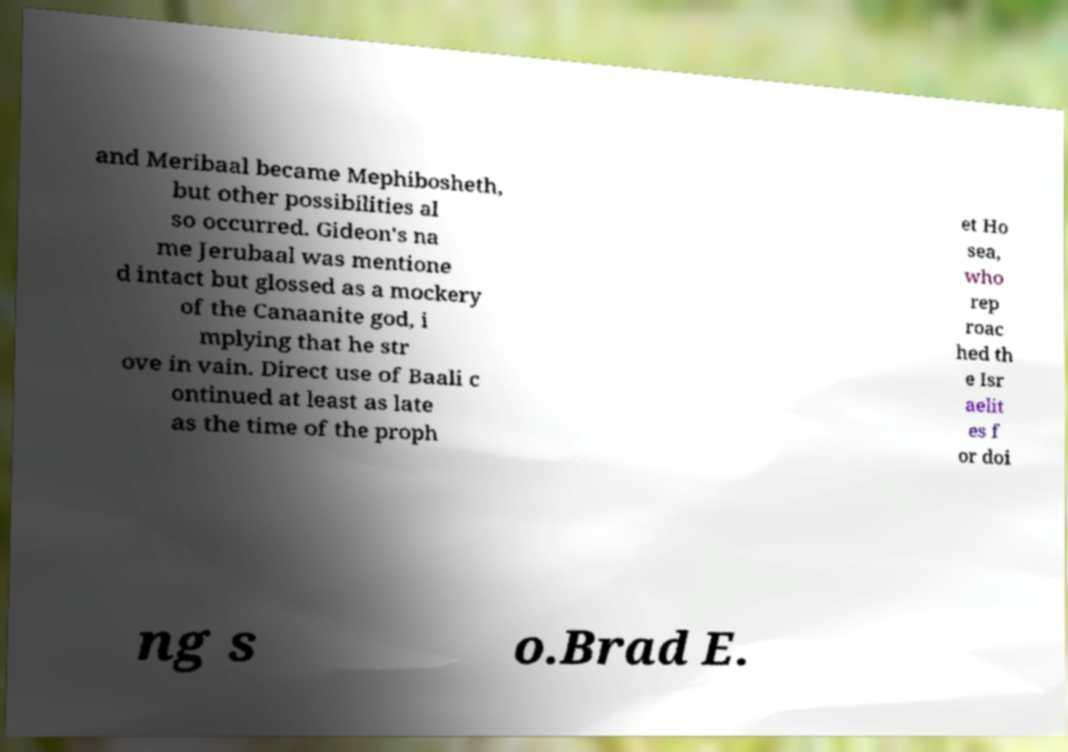Can you accurately transcribe the text from the provided image for me? and Meribaal became Mephibosheth, but other possibilities al so occurred. Gideon's na me Jerubaal was mentione d intact but glossed as a mockery of the Canaanite god, i mplying that he str ove in vain. Direct use of Baali c ontinued at least as late as the time of the proph et Ho sea, who rep roac hed th e Isr aelit es f or doi ng s o.Brad E. 